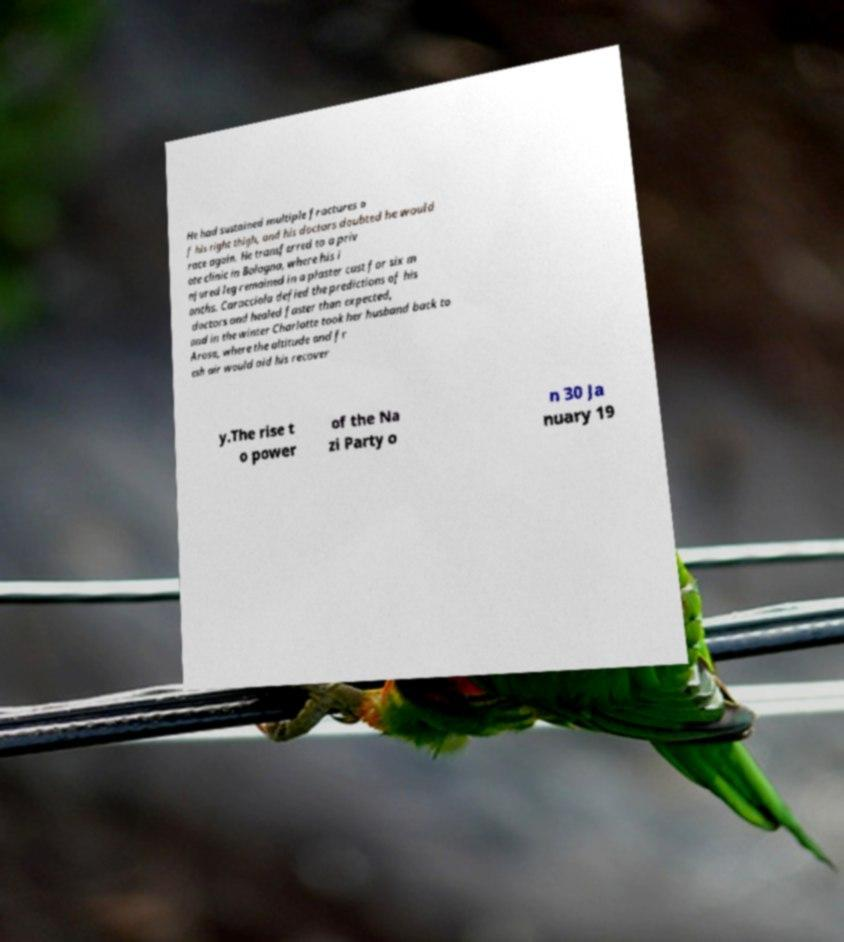Could you assist in decoding the text presented in this image and type it out clearly? He had sustained multiple fractures o f his right thigh, and his doctors doubted he would race again. He transferred to a priv ate clinic in Bologna, where his i njured leg remained in a plaster cast for six m onths. Caracciola defied the predictions of his doctors and healed faster than expected, and in the winter Charlotte took her husband back to Arosa, where the altitude and fr esh air would aid his recover y.The rise t o power of the Na zi Party o n 30 Ja nuary 19 